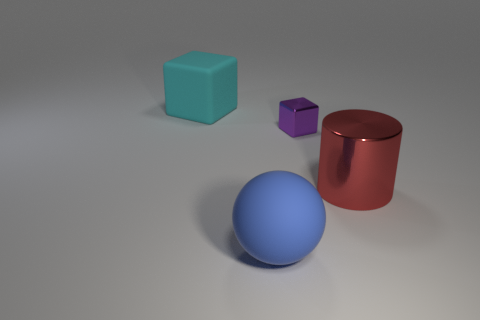There is a matte object that is in front of the large block; is it the same color as the big cylinder?
Keep it short and to the point. No. Are there fewer purple objects left of the purple shiny cube than blue matte balls?
Your answer should be compact. Yes. There is another object that is made of the same material as the big blue object; what color is it?
Offer a very short reply. Cyan. How big is the rubber object in front of the tiny block?
Your answer should be very brief. Large. Are the blue sphere and the tiny object made of the same material?
Give a very brief answer. No. Are there any blue things behind the rubber object that is behind the metal object on the right side of the small object?
Offer a very short reply. No. What is the color of the metallic block?
Make the answer very short. Purple. What color is the matte sphere that is the same size as the metal cylinder?
Keep it short and to the point. Blue. Is the shape of the object on the left side of the large sphere the same as  the red object?
Offer a terse response. No. There is a big object that is to the right of the big matte object that is in front of the big object that is to the right of the sphere; what color is it?
Offer a terse response. Red. 